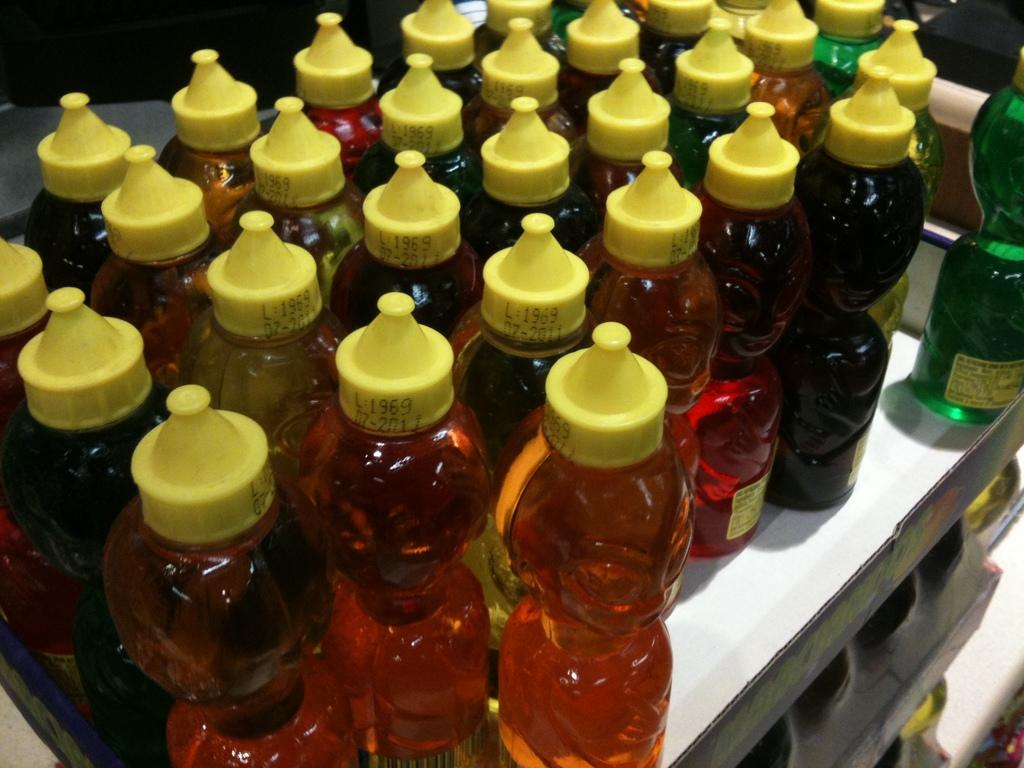What is the main subject of the image? The main subject of the image is a bunch of cool drink bottles. Where are the cool drink bottles located in the image? The cool drink bottles are kept on a table. How many nails are used to hold the mice in the image? There are no nails or mice present in the image; it features a bunch of cool drink bottles on a table. 